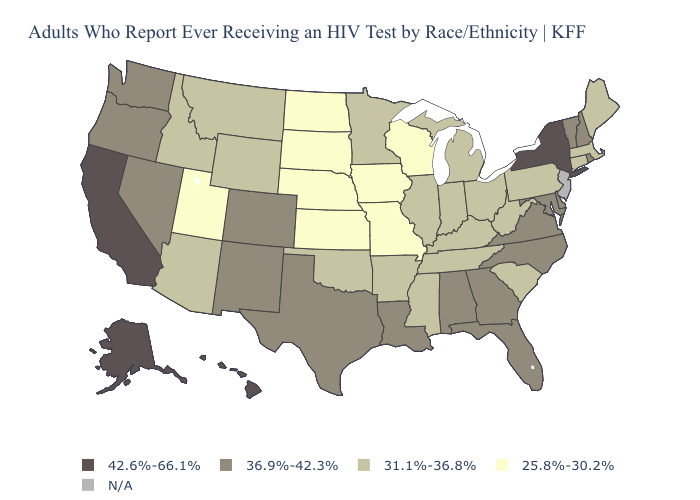Does Hawaii have the lowest value in the USA?
Short answer required. No. Does Nevada have the highest value in the West?
Write a very short answer. No. Does Missouri have the lowest value in the USA?
Keep it brief. Yes. What is the value of Arkansas?
Concise answer only. 31.1%-36.8%. Among the states that border South Dakota , which have the lowest value?
Quick response, please. Iowa, Nebraska, North Dakota. How many symbols are there in the legend?
Quick response, please. 5. What is the lowest value in the USA?
Short answer required. 25.8%-30.2%. Among the states that border Vermont , which have the highest value?
Short answer required. New York. What is the value of Arizona?
Answer briefly. 31.1%-36.8%. Name the states that have a value in the range 25.8%-30.2%?
Keep it brief. Iowa, Kansas, Missouri, Nebraska, North Dakota, South Dakota, Utah, Wisconsin. What is the value of New Mexico?
Concise answer only. 36.9%-42.3%. Name the states that have a value in the range 25.8%-30.2%?
Answer briefly. Iowa, Kansas, Missouri, Nebraska, North Dakota, South Dakota, Utah, Wisconsin. What is the lowest value in the West?
Answer briefly. 25.8%-30.2%. 